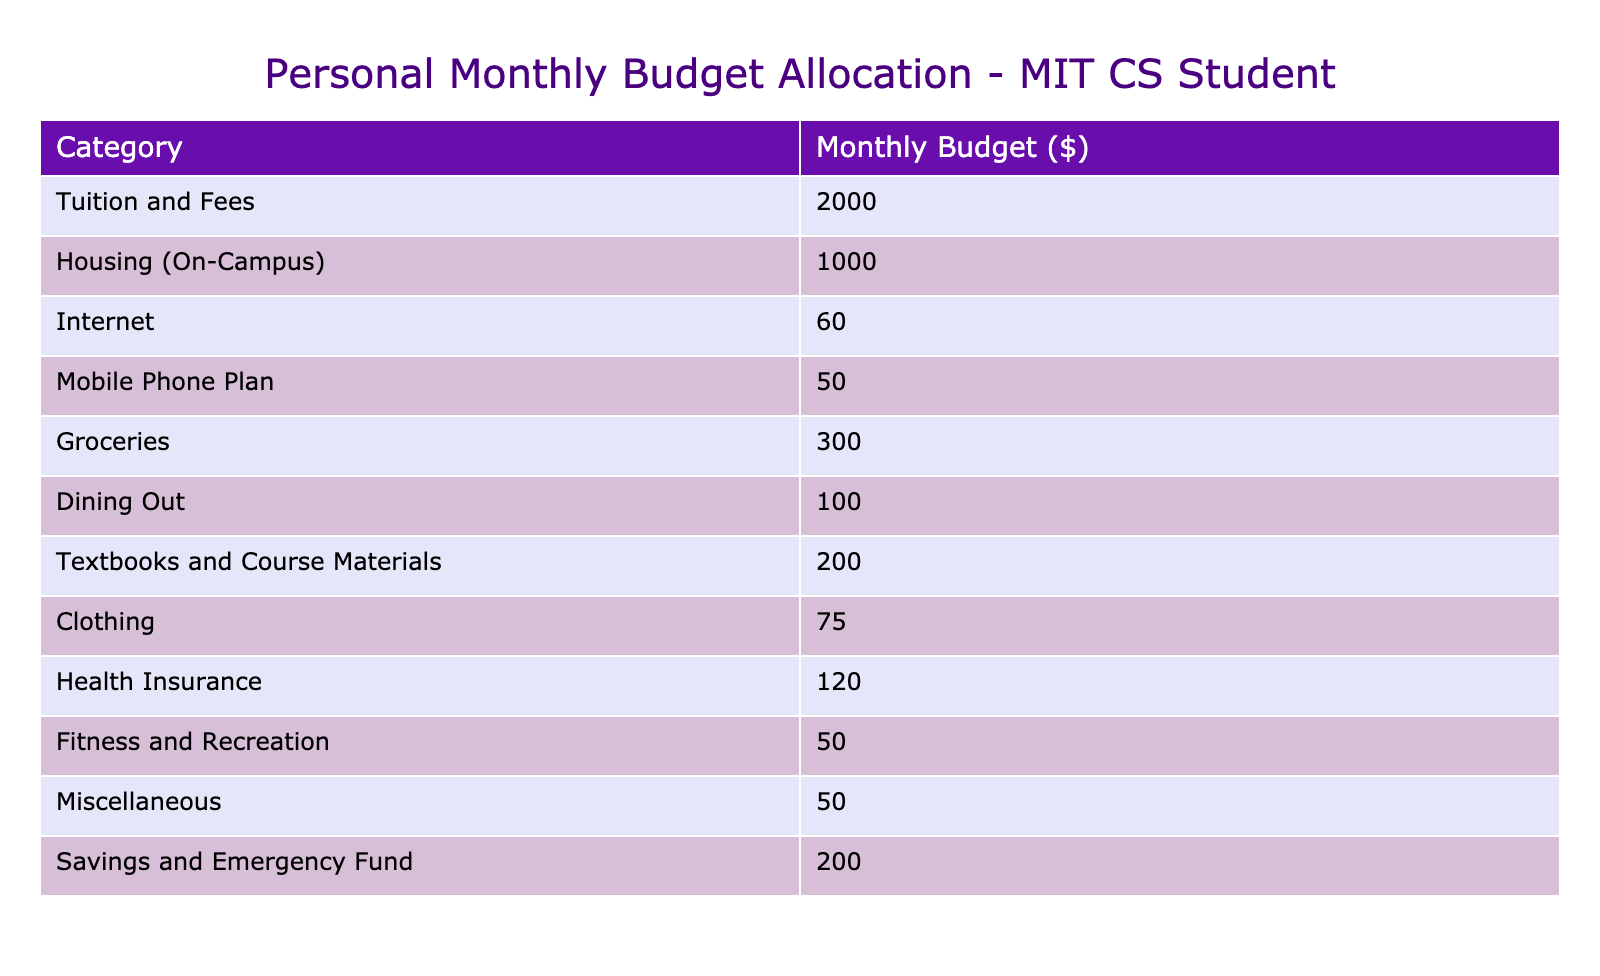What is the total monthly budget allocation for housing, internet, and mobile phone plan? To find the total, first, we identify the budget allocations for these categories: Housing is 1000, Internet is 60, and Mobile Phone Plan is 50. We then add them: 1000 + 60 + 50 = 1110.
Answer: 1110 How much is allocated for fitness and recreation? The table lists the budget for Fitness and Recreation, which is directly stated as 50.
Answer: 50 Is the budget for dining out greater than the budget for clothing? The budget for Dining Out is 100, while for Clothing it is 75. Since 100 is greater than 75, the statement is true.
Answer: Yes What percentage of the total budget is allocated to textbooks and course materials? First, we calculate the total budget by adding all the categories: 2000 + 1000 + 60 + 50 + 300 + 100 + 200 + 75 + 120 + 50 + 50 + 200 = 4005. Textbooks and Course Materials budget is 200. Now, to find the percentage, we divide 200 by 4005 and multiply by 100: (200 / 4005) * 100 ≈ 4.99%.
Answer: Approximately 4.99% What is the difference in budget allocation between savings and emergency fund and health insurance? The budget for Savings and Emergency Fund is 200, while that for Health Insurance is 120. To find the difference, we subtract: 200 - 120 = 80.
Answer: 80 What is the total amount allocated to miscellaneous expenses? The budget for Miscellaneous is explicitly listed in the table as 50.
Answer: 50 Is the combined budget for groceries and dining out less than the budget for housing? The budget for Groceries is 300 and for Dining Out is 100. Their combined total is 300 + 100 = 400. The Housing budget is 1000. Since 400 is less than 1000, the statement is true.
Answer: Yes What is the average monthly budget across all categories? There are 12 categories. The total budget is calculated as previously mentioned, which equals 4005. To find the average, we divide the total by the number of categories: 4005 / 12 ≈ 333.75.
Answer: Approximately 333.75 